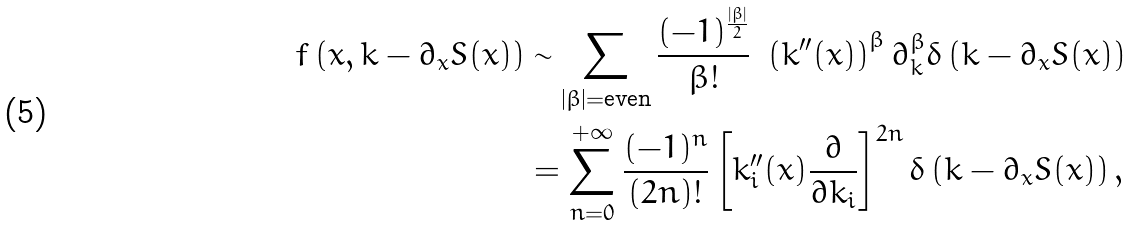<formula> <loc_0><loc_0><loc_500><loc_500>f \left ( x , k - \partial _ { x } S ( x ) \right ) & \sim \sum _ { | \beta | = \text {even} } \frac { ( - 1 ) ^ { \frac { | \beta | } { 2 } } } { \beta ! } \ \left ( k ^ { \prime \prime } ( x ) \right ) ^ { \beta } \partial _ { k } ^ { \beta } \delta \left ( k - \partial _ { x } S ( x ) \right ) \\ & = \sum _ { n = 0 } ^ { + \infty } \frac { ( - 1 ) ^ { n } } { ( 2 n ) ! } \left [ k ^ { \prime \prime } _ { i } ( x ) \frac { \partial } { \partial k _ { i } } \right ] ^ { 2 n } \delta \left ( k - \partial _ { x } S ( x ) \right ) ,</formula> 